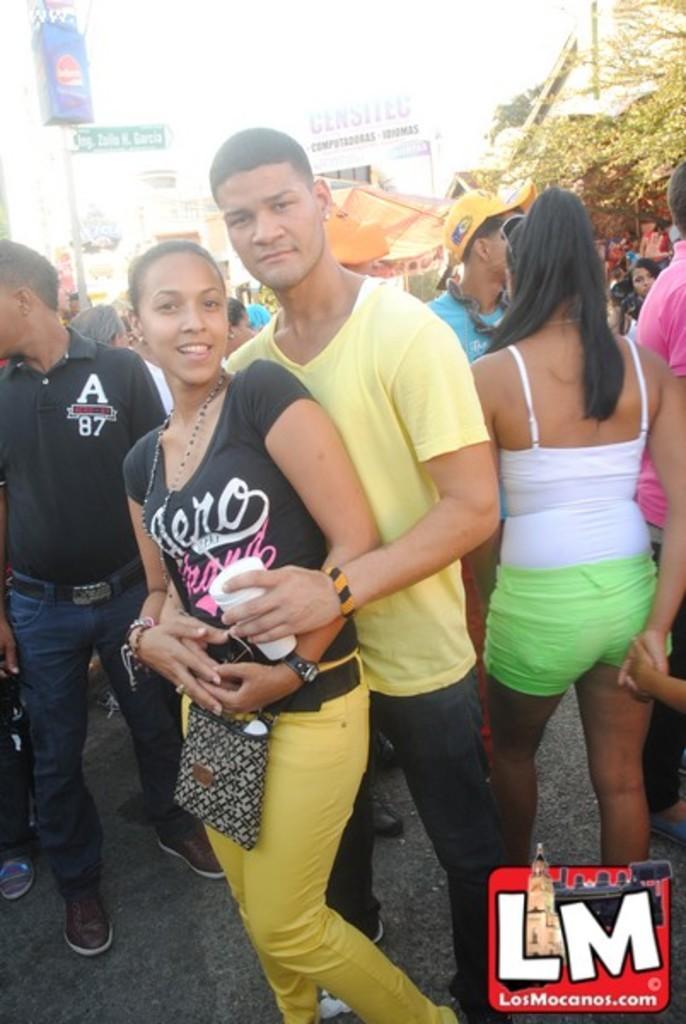In one or two sentences, can you explain what this image depicts? In this image we can see a man holding a woman. In the background it is blur. There are people, boards and a tree. In the bottom right corner of the image we can see watermark. 